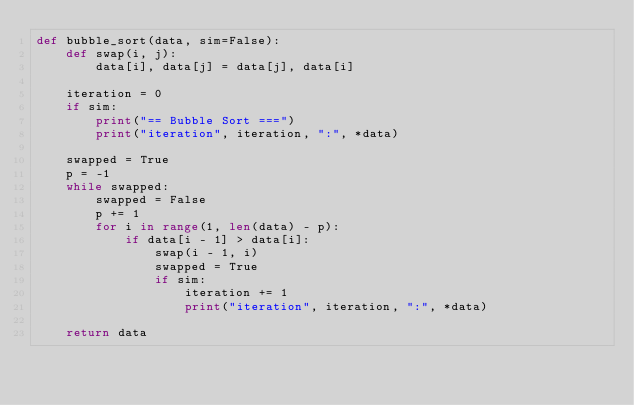<code> <loc_0><loc_0><loc_500><loc_500><_Python_>def bubble_sort(data, sim=False):
    def swap(i, j):
        data[i], data[j] = data[j], data[i]

    iteration = 0
    if sim:
        print("== Bubble Sort ===")
        print("iteration", iteration, ":", *data)

    swapped = True
    p = -1
    while swapped:
        swapped = False
        p += 1
        for i in range(1, len(data) - p):
            if data[i - 1] > data[i]:
                swap(i - 1, i)
                swapped = True
                if sim:
                    iteration += 1
                    print("iteration", iteration, ":", *data)

    return data
</code> 